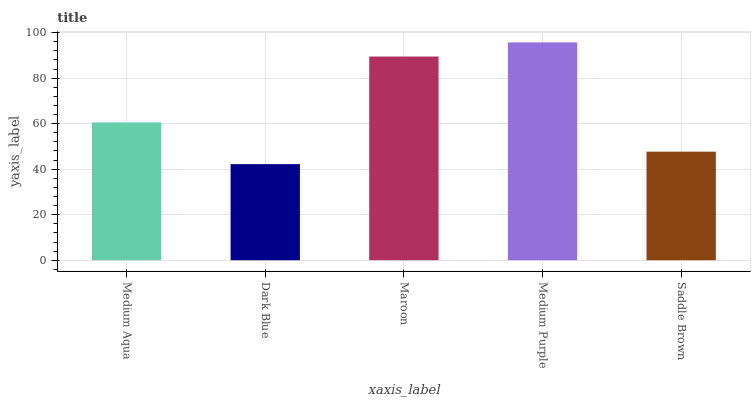Is Dark Blue the minimum?
Answer yes or no. Yes. Is Medium Purple the maximum?
Answer yes or no. Yes. Is Maroon the minimum?
Answer yes or no. No. Is Maroon the maximum?
Answer yes or no. No. Is Maroon greater than Dark Blue?
Answer yes or no. Yes. Is Dark Blue less than Maroon?
Answer yes or no. Yes. Is Dark Blue greater than Maroon?
Answer yes or no. No. Is Maroon less than Dark Blue?
Answer yes or no. No. Is Medium Aqua the high median?
Answer yes or no. Yes. Is Medium Aqua the low median?
Answer yes or no. Yes. Is Medium Purple the high median?
Answer yes or no. No. Is Medium Purple the low median?
Answer yes or no. No. 